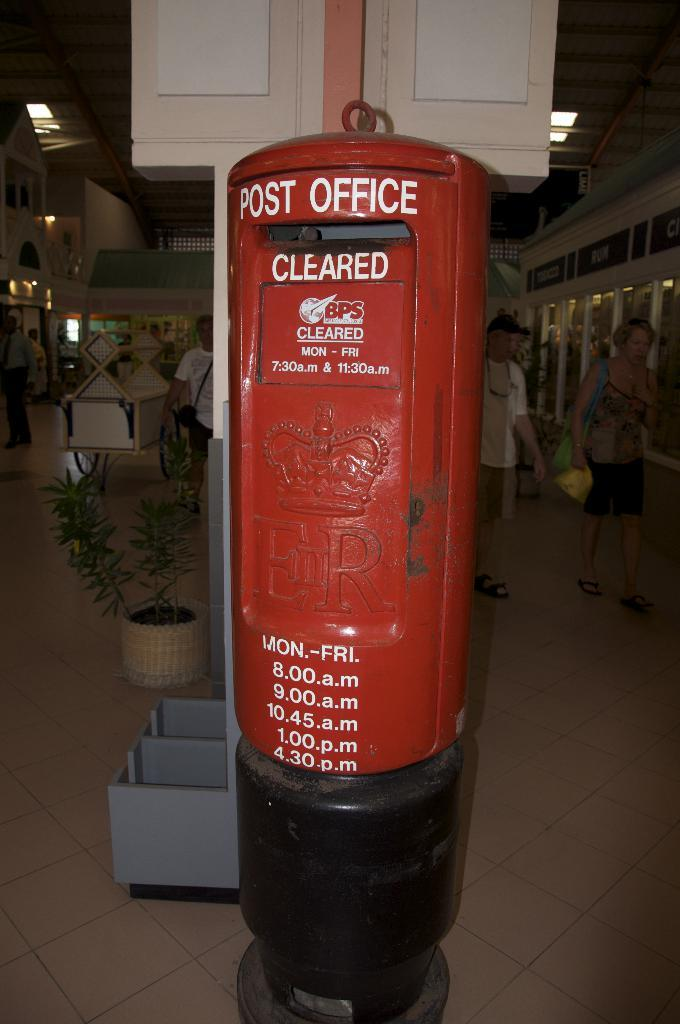What is the main object in the middle of the image? There is a post box in the middle of the image. What else can be seen near the post box? There are plants beside the post box. What activity are two people engaged in on the right side of the image? Two persons are walking on the right side of the image. What type of lighting is visible at the top of the image? Ceiling lights are visible at the top of the image. What type of pancake is being served in the lunchroom in the image? There is no lunchroom or pancake present in the image. How many fingers can be seen on the person's hand in the image? There are no visible hands or fingers in the image. 